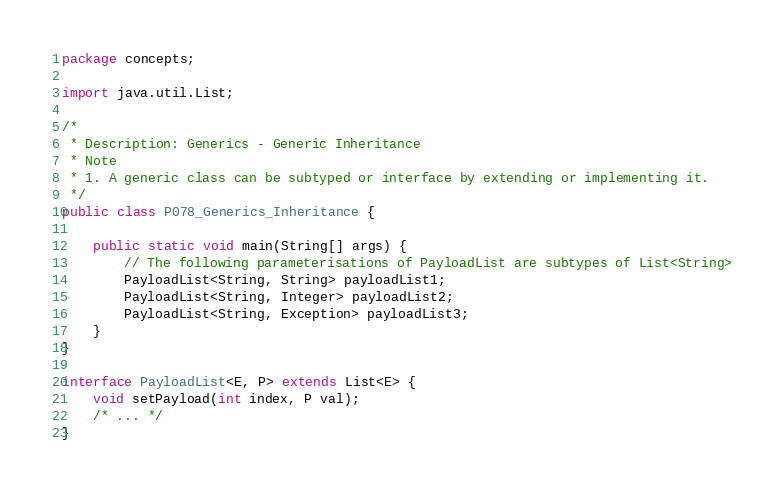<code> <loc_0><loc_0><loc_500><loc_500><_Java_>package concepts;

import java.util.List;

/*
 * Description: Generics - Generic Inheritance
 * Note
 * 1. A generic class can be subtyped or interface by extending or implementing it.
 */
public class P078_Generics_Inheritance {

    public static void main(String[] args) {
        // The following parameterisations of PayloadList are subtypes of List<String>
        PayloadList<String, String> payloadList1;
        PayloadList<String, Integer> payloadList2;
        PayloadList<String, Exception> payloadList3;
    }
}

interface PayloadList<E, P> extends List<E> {
    void setPayload(int index, P val);
    /* ... */
}</code> 